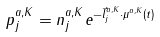<formula> <loc_0><loc_0><loc_500><loc_500>p _ { j } ^ { a , K } = n _ { j } ^ { a , K } e ^ { - \vec { l } _ { j } ^ { a , K } \cdot \mu ^ { a , K } ( t ) }</formula> 